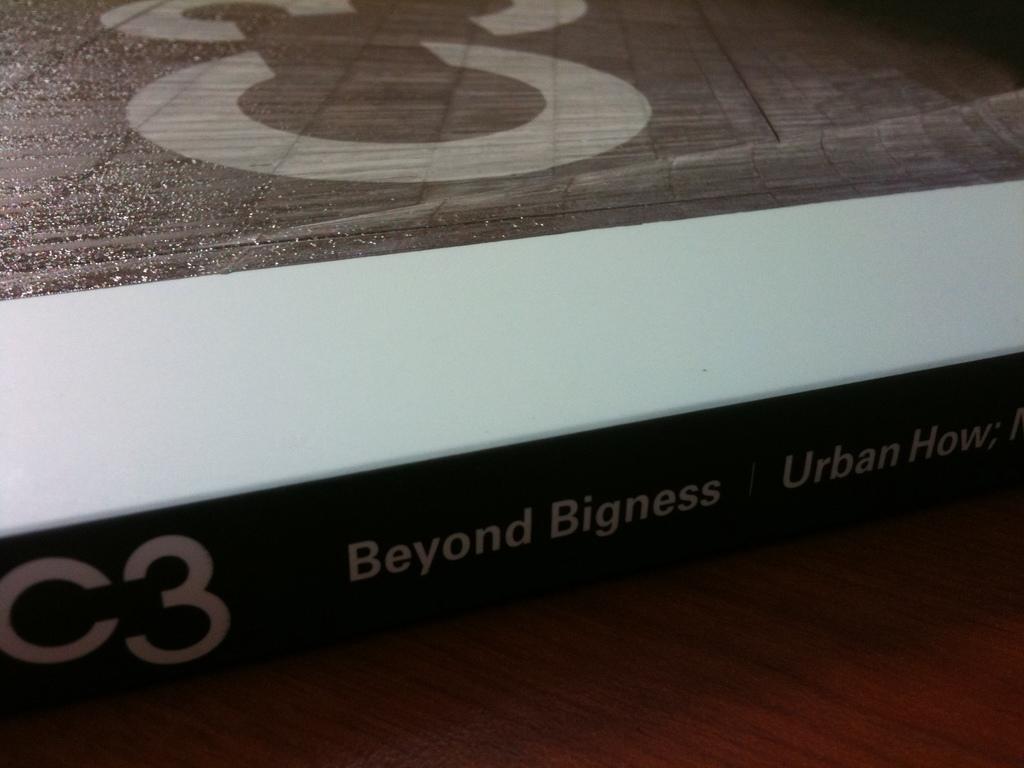What is the letter/number combination on this item?
Ensure brevity in your answer.  C3. 